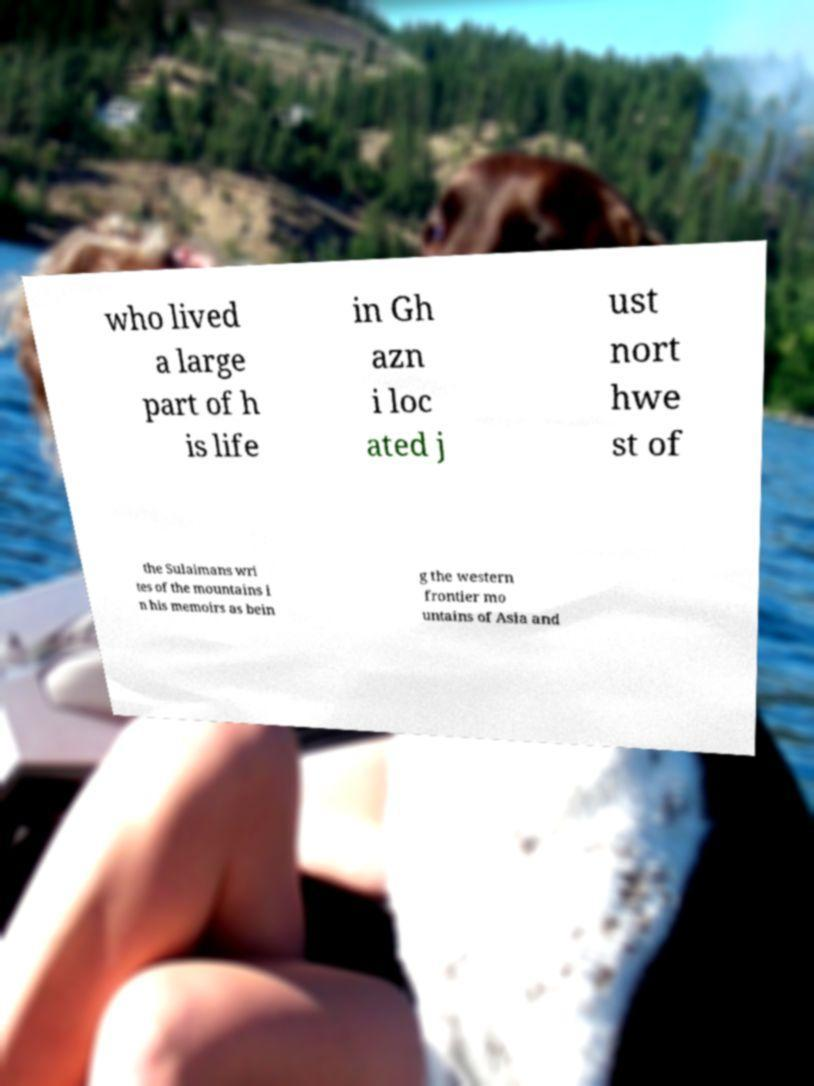There's text embedded in this image that I need extracted. Can you transcribe it verbatim? who lived a large part of h is life in Gh azn i loc ated j ust nort hwe st of the Sulaimans wri tes of the mountains i n his memoirs as bein g the western frontier mo untains of Asia and 